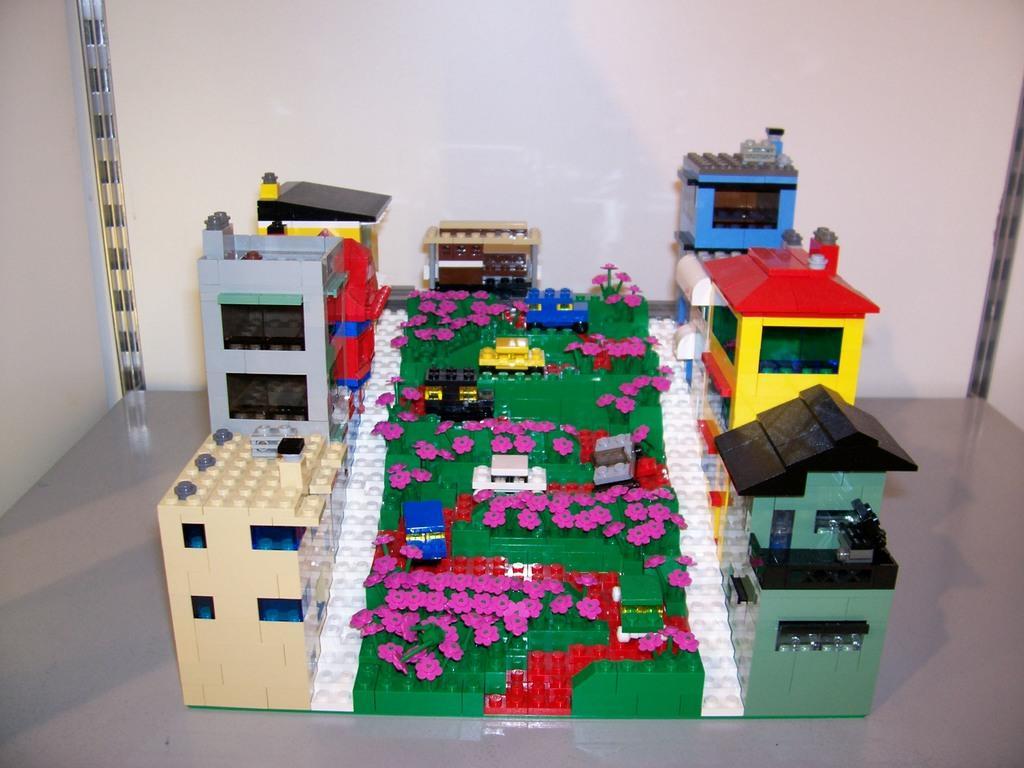Can you describe this image briefly? In this image we can see Lego toys. In the background of the image there is wall. At the bottom of the image there is floor. 